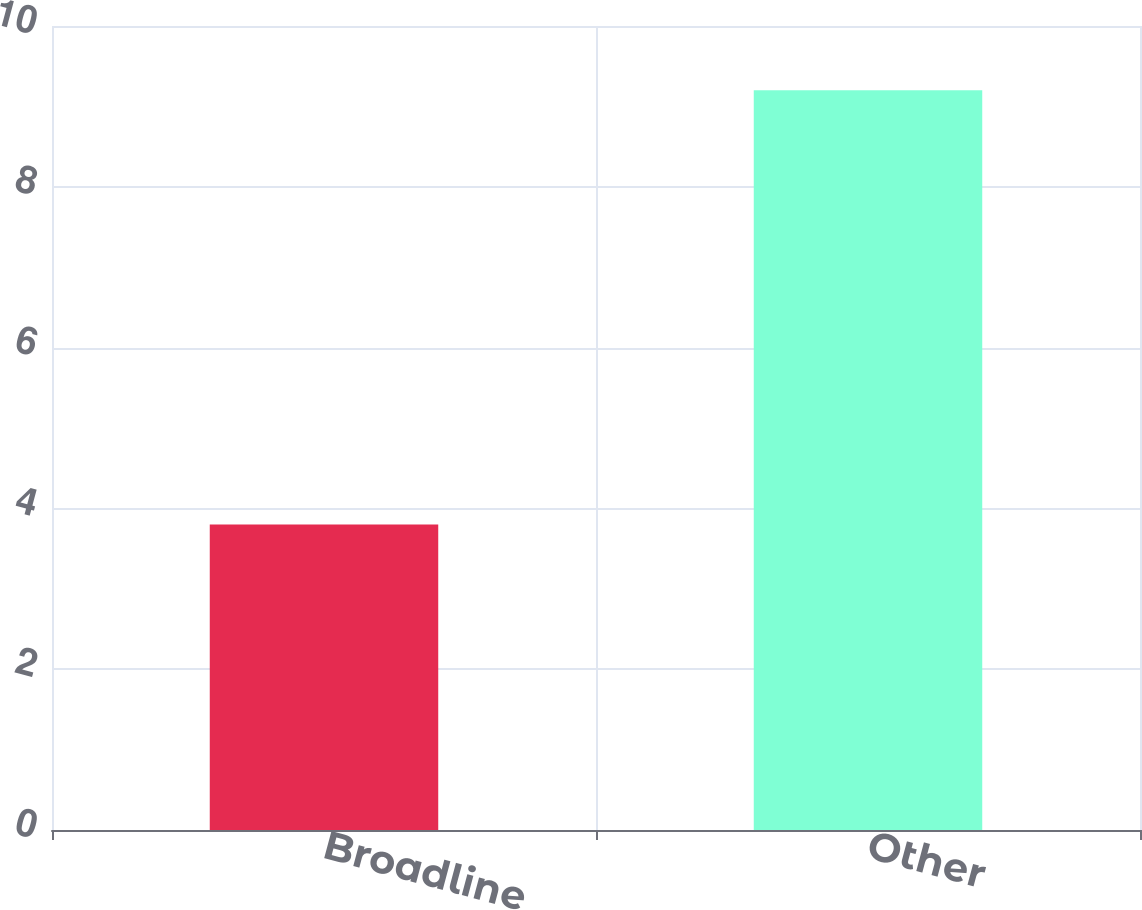Convert chart. <chart><loc_0><loc_0><loc_500><loc_500><bar_chart><fcel>Broadline<fcel>Other<nl><fcel>3.8<fcel>9.2<nl></chart> 